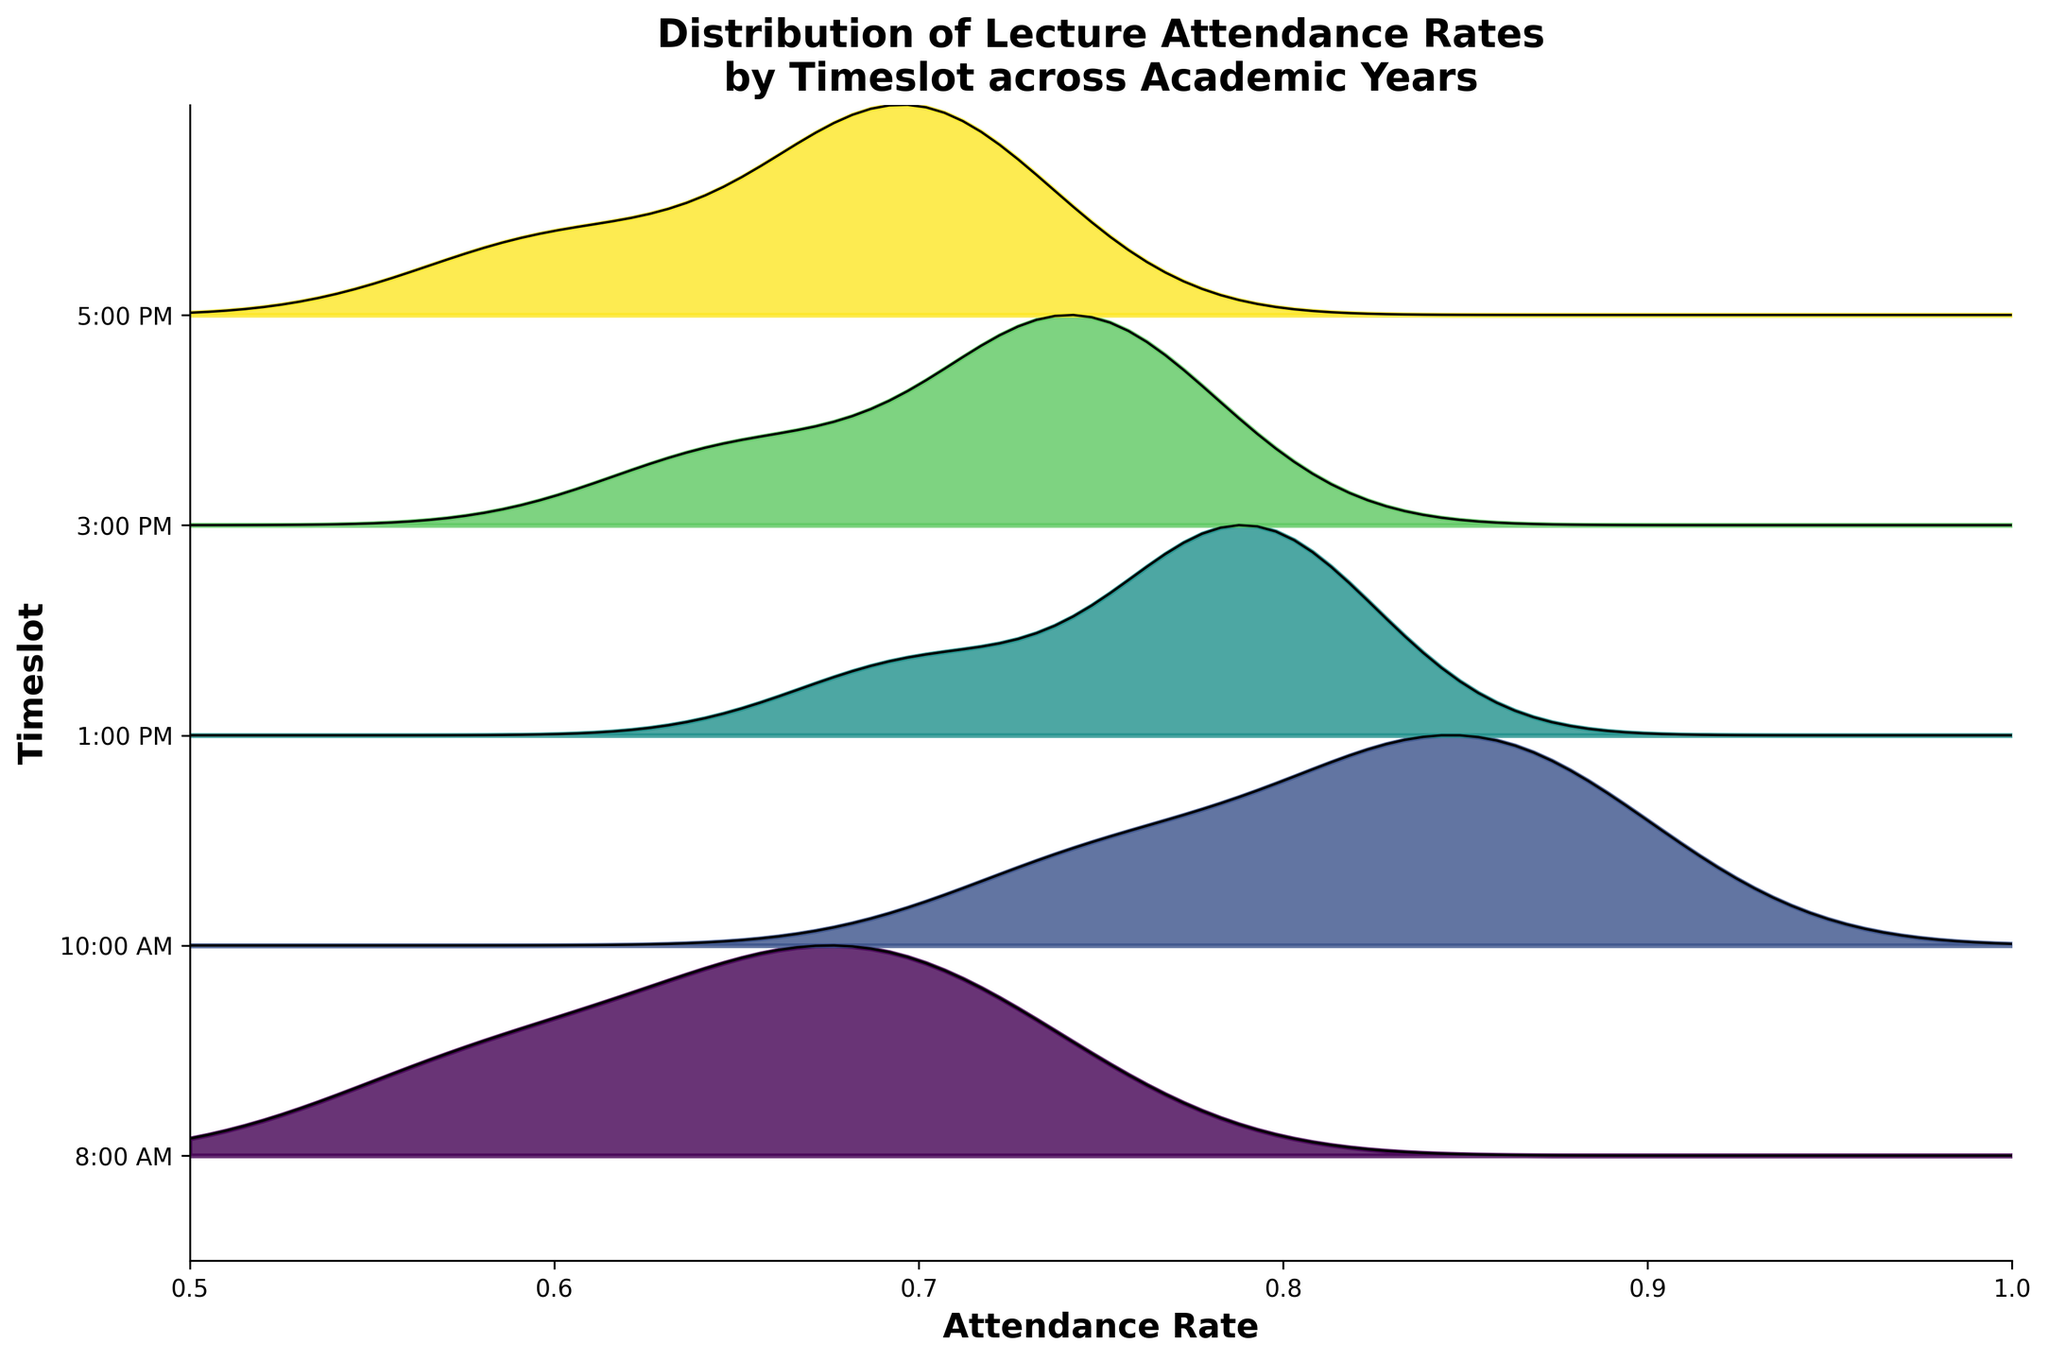What is the title of the plot? The title of the plot is written at the top and gives an idea of the data visualized. It indicates both the main variable and the comparative dimensions.
Answer: Distribution of Lecture Attendance Rates by Timeslot across Academic Years What do the y-axis labels represent? The y-axis labels are on the left side of the plot and show the different timeslots for lectures. These timeslots help organize and separate the ridgeline distributions.
Answer: Different lecture timeslots Which timeslot has the widest range of attendance rates? To determine the widest range, you should look for the ridgeline with the broadest spread along the x-axis direction.
Answer: 10:00 AM What is the general trend of the attendance rates across different timeslots? By examining the spread and peaks of each ridgeline, you can infer if certain times have higher or lower attendance rates, using overall shapes and positions.
Answer: Generally higher mid-morning and lower in the early morning and late afternoon How do the attendance rates at 8:00 AM compare to those at 3:00 PM? By comparing the ridgeline heights and ranges at each timeslot, we can observe the relative differences.
Answer: 8:00 AM has a slightly higher attendance rate on average than 3:00 PM Which timeslot shows the highest peak in attendance rates? The highest peak on a ridgeline plot indicates the most frequent attendance rate for that timeslot.
Answer: 10:00 AM Is there a significant difference in attendance rates between 10:00 AM and 5:00 PM? We can compare the distribution curves to identify whether one timeslot consistently has higher attendance rates than the other.
Answer: Yes, 10:00 AM is higher Which timeslot has the most consistent attendance rates across years? Consistency can be identified by the narrowest ridgeline over the years, indicating less variation in the attendance rate.
Answer: 10:00 AM What is the range of attendance rates for the 1:00 PM timeslot? The range of attendance rates can be observed by looking at the spread of the ridgeline for 1:00 PM across the x-axis.
Answer: Approximately 0.70 to 0.80 How do the attendance rates at 5:00 PM change over the years? By observing the ridgeline’s movement and spread, we can identify any noticeable year-on-year trends.
Answer: The rates show a slight increase from 2020-2021 to 2022-2023 